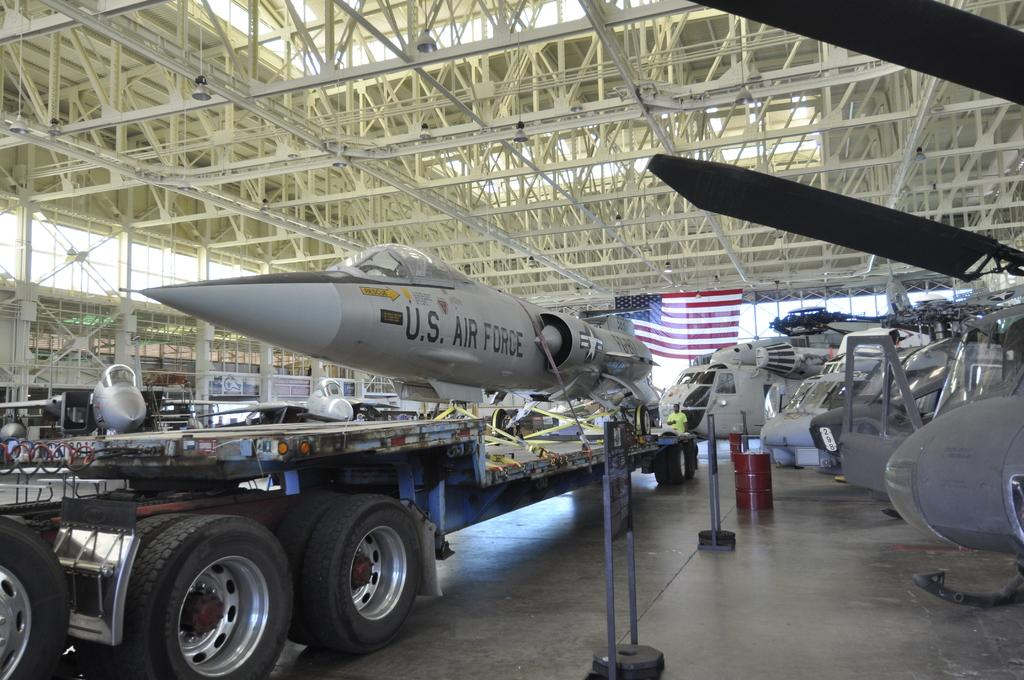<image>
Give a short and clear explanation of the subsequent image. A U.S. Air Force jet is sitting on a trailer in a garage. 